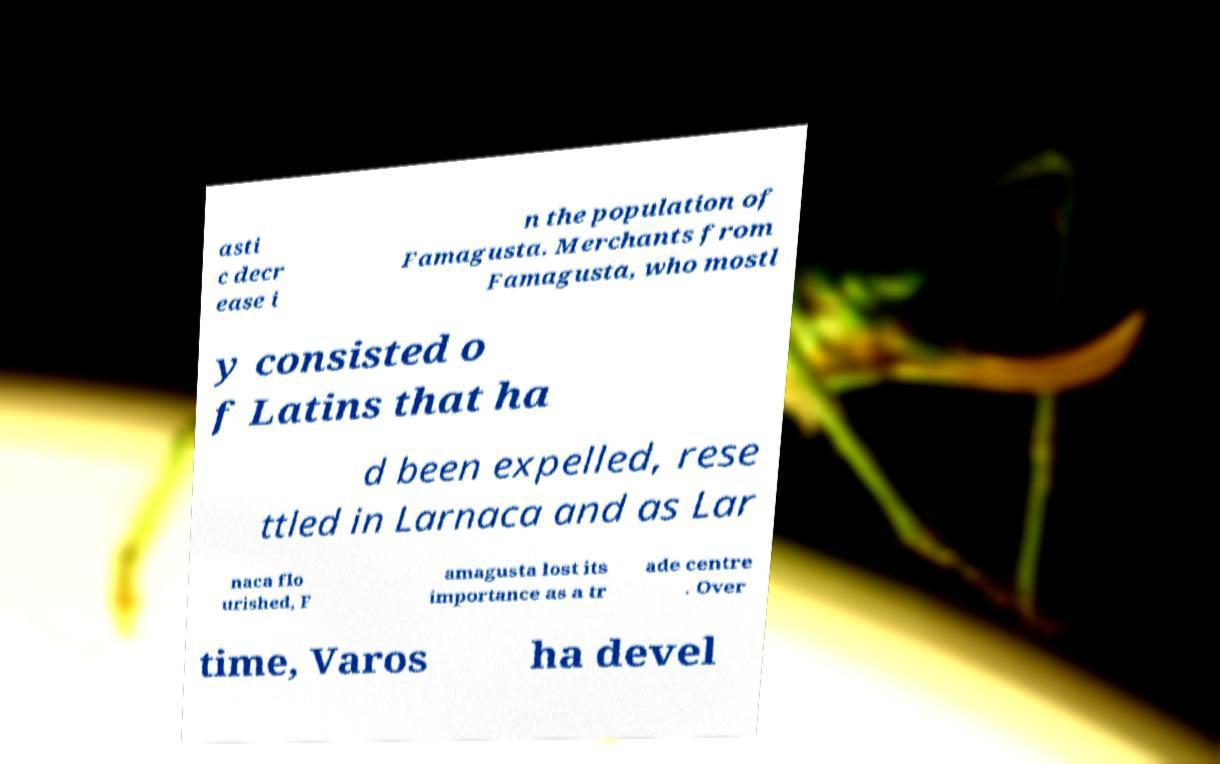What messages or text are displayed in this image? I need them in a readable, typed format. asti c decr ease i n the population of Famagusta. Merchants from Famagusta, who mostl y consisted o f Latins that ha d been expelled, rese ttled in Larnaca and as Lar naca flo urished, F amagusta lost its importance as a tr ade centre . Over time, Varos ha devel 